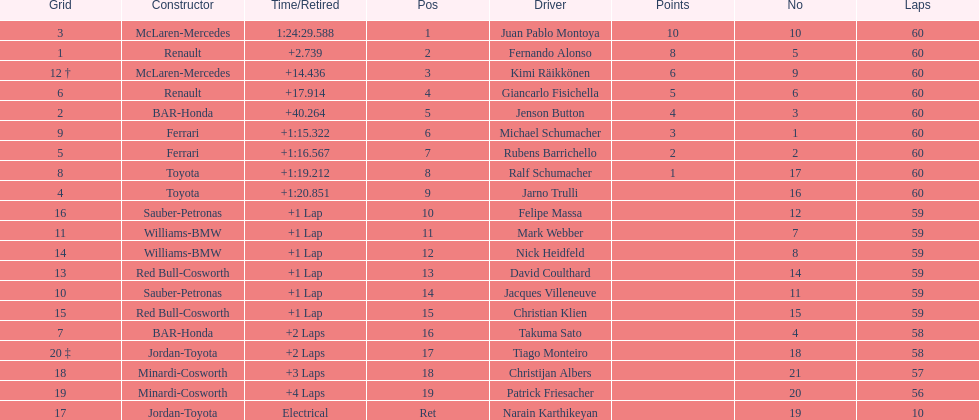Would you be able to parse every entry in this table? {'header': ['Grid', 'Constructor', 'Time/Retired', 'Pos', 'Driver', 'Points', 'No', 'Laps'], 'rows': [['3', 'McLaren-Mercedes', '1:24:29.588', '1', 'Juan Pablo Montoya', '10', '10', '60'], ['1', 'Renault', '+2.739', '2', 'Fernando Alonso', '8', '5', '60'], ['12 †', 'McLaren-Mercedes', '+14.436', '3', 'Kimi Räikkönen', '6', '9', '60'], ['6', 'Renault', '+17.914', '4', 'Giancarlo Fisichella', '5', '6', '60'], ['2', 'BAR-Honda', '+40.264', '5', 'Jenson Button', '4', '3', '60'], ['9', 'Ferrari', '+1:15.322', '6', 'Michael Schumacher', '3', '1', '60'], ['5', 'Ferrari', '+1:16.567', '7', 'Rubens Barrichello', '2', '2', '60'], ['8', 'Toyota', '+1:19.212', '8', 'Ralf Schumacher', '1', '17', '60'], ['4', 'Toyota', '+1:20.851', '9', 'Jarno Trulli', '', '16', '60'], ['16', 'Sauber-Petronas', '+1 Lap', '10', 'Felipe Massa', '', '12', '59'], ['11', 'Williams-BMW', '+1 Lap', '11', 'Mark Webber', '', '7', '59'], ['14', 'Williams-BMW', '+1 Lap', '12', 'Nick Heidfeld', '', '8', '59'], ['13', 'Red Bull-Cosworth', '+1 Lap', '13', 'David Coulthard', '', '14', '59'], ['10', 'Sauber-Petronas', '+1 Lap', '14', 'Jacques Villeneuve', '', '11', '59'], ['15', 'Red Bull-Cosworth', '+1 Lap', '15', 'Christian Klien', '', '15', '59'], ['7', 'BAR-Honda', '+2 Laps', '16', 'Takuma Sato', '', '4', '58'], ['20 ‡', 'Jordan-Toyota', '+2 Laps', '17', 'Tiago Monteiro', '', '18', '58'], ['18', 'Minardi-Cosworth', '+3 Laps', '18', 'Christijan Albers', '', '21', '57'], ['19', 'Minardi-Cosworth', '+4 Laps', '19', 'Patrick Friesacher', '', '20', '56'], ['17', 'Jordan-Toyota', 'Electrical', 'Ret', 'Narain Karthikeyan', '', '19', '10']]} How many drivers received points from the race? 8. 